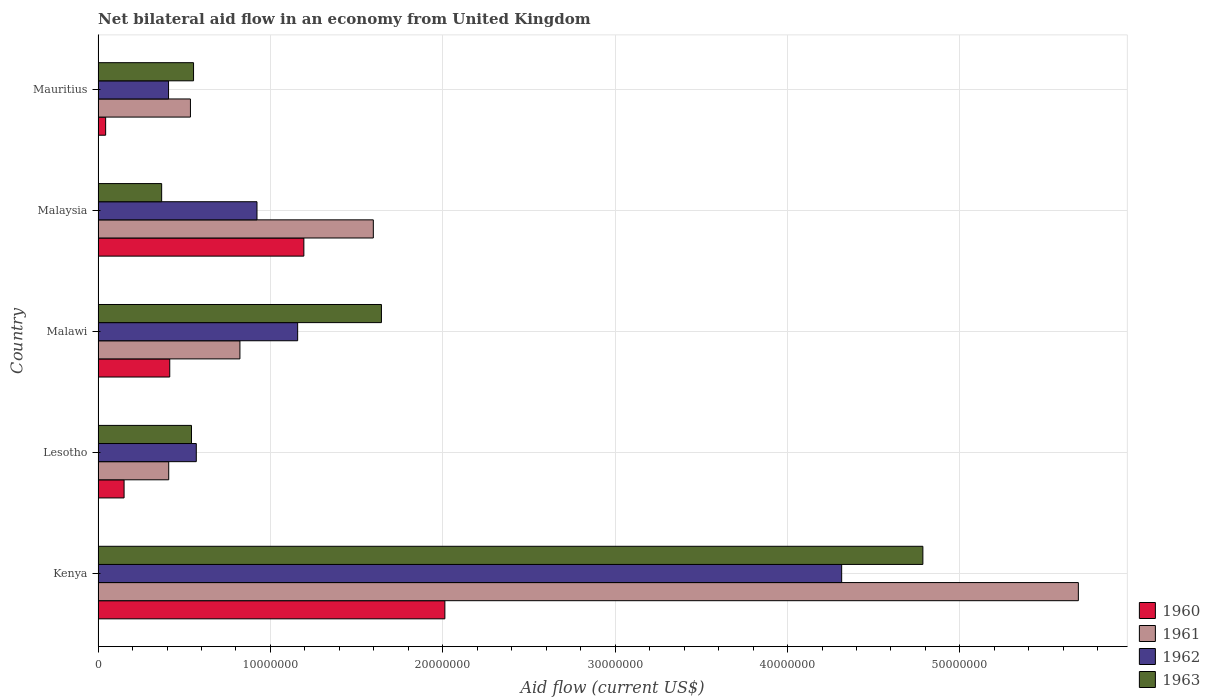How many different coloured bars are there?
Provide a succinct answer. 4. How many groups of bars are there?
Make the answer very short. 5. Are the number of bars per tick equal to the number of legend labels?
Ensure brevity in your answer.  Yes. Are the number of bars on each tick of the Y-axis equal?
Ensure brevity in your answer.  Yes. How many bars are there on the 5th tick from the top?
Your answer should be very brief. 4. What is the label of the 1st group of bars from the top?
Ensure brevity in your answer.  Mauritius. What is the net bilateral aid flow in 1960 in Malawi?
Ensure brevity in your answer.  4.16e+06. Across all countries, what is the maximum net bilateral aid flow in 1960?
Provide a short and direct response. 2.01e+07. Across all countries, what is the minimum net bilateral aid flow in 1963?
Offer a very short reply. 3.69e+06. In which country was the net bilateral aid flow in 1962 maximum?
Keep it short and to the point. Kenya. In which country was the net bilateral aid flow in 1960 minimum?
Your answer should be compact. Mauritius. What is the total net bilateral aid flow in 1962 in the graph?
Give a very brief answer. 7.37e+07. What is the difference between the net bilateral aid flow in 1962 in Malawi and that in Malaysia?
Your answer should be compact. 2.36e+06. What is the difference between the net bilateral aid flow in 1963 in Malaysia and the net bilateral aid flow in 1961 in Kenya?
Offer a very short reply. -5.32e+07. What is the average net bilateral aid flow in 1960 per country?
Keep it short and to the point. 7.63e+06. What is the difference between the net bilateral aid flow in 1961 and net bilateral aid flow in 1962 in Kenya?
Your answer should be compact. 1.37e+07. In how many countries, is the net bilateral aid flow in 1960 greater than 14000000 US$?
Keep it short and to the point. 1. What is the ratio of the net bilateral aid flow in 1963 in Kenya to that in Malaysia?
Make the answer very short. 12.97. Is the net bilateral aid flow in 1962 in Malaysia less than that in Mauritius?
Your answer should be compact. No. Is the difference between the net bilateral aid flow in 1961 in Kenya and Mauritius greater than the difference between the net bilateral aid flow in 1962 in Kenya and Mauritius?
Offer a terse response. Yes. What is the difference between the highest and the second highest net bilateral aid flow in 1962?
Your answer should be compact. 3.16e+07. What is the difference between the highest and the lowest net bilateral aid flow in 1963?
Offer a very short reply. 4.42e+07. In how many countries, is the net bilateral aid flow in 1963 greater than the average net bilateral aid flow in 1963 taken over all countries?
Provide a short and direct response. 2. What does the 3rd bar from the bottom in Kenya represents?
Offer a terse response. 1962. How many bars are there?
Your answer should be very brief. 20. How many countries are there in the graph?
Give a very brief answer. 5. What is the difference between two consecutive major ticks on the X-axis?
Keep it short and to the point. 1.00e+07. Are the values on the major ticks of X-axis written in scientific E-notation?
Keep it short and to the point. No. Does the graph contain any zero values?
Offer a terse response. No. Where does the legend appear in the graph?
Offer a terse response. Bottom right. How are the legend labels stacked?
Offer a terse response. Vertical. What is the title of the graph?
Keep it short and to the point. Net bilateral aid flow in an economy from United Kingdom. What is the label or title of the X-axis?
Ensure brevity in your answer.  Aid flow (current US$). What is the label or title of the Y-axis?
Your response must be concise. Country. What is the Aid flow (current US$) in 1960 in Kenya?
Provide a succinct answer. 2.01e+07. What is the Aid flow (current US$) in 1961 in Kenya?
Provide a short and direct response. 5.69e+07. What is the Aid flow (current US$) in 1962 in Kenya?
Your response must be concise. 4.31e+07. What is the Aid flow (current US$) in 1963 in Kenya?
Offer a terse response. 4.78e+07. What is the Aid flow (current US$) of 1960 in Lesotho?
Make the answer very short. 1.51e+06. What is the Aid flow (current US$) in 1961 in Lesotho?
Give a very brief answer. 4.10e+06. What is the Aid flow (current US$) of 1962 in Lesotho?
Offer a very short reply. 5.70e+06. What is the Aid flow (current US$) in 1963 in Lesotho?
Keep it short and to the point. 5.42e+06. What is the Aid flow (current US$) of 1960 in Malawi?
Your answer should be very brief. 4.16e+06. What is the Aid flow (current US$) of 1961 in Malawi?
Make the answer very short. 8.23e+06. What is the Aid flow (current US$) of 1962 in Malawi?
Your answer should be very brief. 1.16e+07. What is the Aid flow (current US$) of 1963 in Malawi?
Give a very brief answer. 1.64e+07. What is the Aid flow (current US$) in 1960 in Malaysia?
Offer a terse response. 1.19e+07. What is the Aid flow (current US$) of 1961 in Malaysia?
Your answer should be compact. 1.60e+07. What is the Aid flow (current US$) in 1962 in Malaysia?
Make the answer very short. 9.22e+06. What is the Aid flow (current US$) of 1963 in Malaysia?
Keep it short and to the point. 3.69e+06. What is the Aid flow (current US$) of 1960 in Mauritius?
Give a very brief answer. 4.40e+05. What is the Aid flow (current US$) in 1961 in Mauritius?
Make the answer very short. 5.36e+06. What is the Aid flow (current US$) in 1962 in Mauritius?
Ensure brevity in your answer.  4.09e+06. What is the Aid flow (current US$) in 1963 in Mauritius?
Offer a terse response. 5.54e+06. Across all countries, what is the maximum Aid flow (current US$) of 1960?
Keep it short and to the point. 2.01e+07. Across all countries, what is the maximum Aid flow (current US$) in 1961?
Provide a short and direct response. 5.69e+07. Across all countries, what is the maximum Aid flow (current US$) in 1962?
Ensure brevity in your answer.  4.31e+07. Across all countries, what is the maximum Aid flow (current US$) of 1963?
Give a very brief answer. 4.78e+07. Across all countries, what is the minimum Aid flow (current US$) in 1961?
Make the answer very short. 4.10e+06. Across all countries, what is the minimum Aid flow (current US$) in 1962?
Provide a short and direct response. 4.09e+06. Across all countries, what is the minimum Aid flow (current US$) of 1963?
Offer a very short reply. 3.69e+06. What is the total Aid flow (current US$) in 1960 in the graph?
Your response must be concise. 3.82e+07. What is the total Aid flow (current US$) in 1961 in the graph?
Offer a very short reply. 9.05e+07. What is the total Aid flow (current US$) of 1962 in the graph?
Offer a terse response. 7.37e+07. What is the total Aid flow (current US$) of 1963 in the graph?
Keep it short and to the point. 7.89e+07. What is the difference between the Aid flow (current US$) in 1960 in Kenya and that in Lesotho?
Provide a short and direct response. 1.86e+07. What is the difference between the Aid flow (current US$) of 1961 in Kenya and that in Lesotho?
Ensure brevity in your answer.  5.28e+07. What is the difference between the Aid flow (current US$) in 1962 in Kenya and that in Lesotho?
Your response must be concise. 3.74e+07. What is the difference between the Aid flow (current US$) in 1963 in Kenya and that in Lesotho?
Your answer should be compact. 4.24e+07. What is the difference between the Aid flow (current US$) of 1960 in Kenya and that in Malawi?
Your answer should be very brief. 1.60e+07. What is the difference between the Aid flow (current US$) of 1961 in Kenya and that in Malawi?
Your answer should be very brief. 4.86e+07. What is the difference between the Aid flow (current US$) of 1962 in Kenya and that in Malawi?
Offer a terse response. 3.16e+07. What is the difference between the Aid flow (current US$) of 1963 in Kenya and that in Malawi?
Ensure brevity in your answer.  3.14e+07. What is the difference between the Aid flow (current US$) of 1960 in Kenya and that in Malaysia?
Make the answer very short. 8.18e+06. What is the difference between the Aid flow (current US$) in 1961 in Kenya and that in Malaysia?
Your answer should be compact. 4.09e+07. What is the difference between the Aid flow (current US$) in 1962 in Kenya and that in Malaysia?
Ensure brevity in your answer.  3.39e+07. What is the difference between the Aid flow (current US$) in 1963 in Kenya and that in Malaysia?
Provide a short and direct response. 4.42e+07. What is the difference between the Aid flow (current US$) of 1960 in Kenya and that in Mauritius?
Ensure brevity in your answer.  1.97e+07. What is the difference between the Aid flow (current US$) of 1961 in Kenya and that in Mauritius?
Ensure brevity in your answer.  5.15e+07. What is the difference between the Aid flow (current US$) in 1962 in Kenya and that in Mauritius?
Offer a terse response. 3.90e+07. What is the difference between the Aid flow (current US$) in 1963 in Kenya and that in Mauritius?
Offer a very short reply. 4.23e+07. What is the difference between the Aid flow (current US$) of 1960 in Lesotho and that in Malawi?
Provide a short and direct response. -2.65e+06. What is the difference between the Aid flow (current US$) of 1961 in Lesotho and that in Malawi?
Offer a very short reply. -4.13e+06. What is the difference between the Aid flow (current US$) in 1962 in Lesotho and that in Malawi?
Ensure brevity in your answer.  -5.88e+06. What is the difference between the Aid flow (current US$) in 1963 in Lesotho and that in Malawi?
Make the answer very short. -1.10e+07. What is the difference between the Aid flow (current US$) of 1960 in Lesotho and that in Malaysia?
Provide a succinct answer. -1.04e+07. What is the difference between the Aid flow (current US$) of 1961 in Lesotho and that in Malaysia?
Give a very brief answer. -1.19e+07. What is the difference between the Aid flow (current US$) in 1962 in Lesotho and that in Malaysia?
Make the answer very short. -3.52e+06. What is the difference between the Aid flow (current US$) in 1963 in Lesotho and that in Malaysia?
Your response must be concise. 1.73e+06. What is the difference between the Aid flow (current US$) in 1960 in Lesotho and that in Mauritius?
Ensure brevity in your answer.  1.07e+06. What is the difference between the Aid flow (current US$) of 1961 in Lesotho and that in Mauritius?
Keep it short and to the point. -1.26e+06. What is the difference between the Aid flow (current US$) in 1962 in Lesotho and that in Mauritius?
Your response must be concise. 1.61e+06. What is the difference between the Aid flow (current US$) in 1960 in Malawi and that in Malaysia?
Provide a succinct answer. -7.78e+06. What is the difference between the Aid flow (current US$) of 1961 in Malawi and that in Malaysia?
Ensure brevity in your answer.  -7.74e+06. What is the difference between the Aid flow (current US$) in 1962 in Malawi and that in Malaysia?
Offer a very short reply. 2.36e+06. What is the difference between the Aid flow (current US$) of 1963 in Malawi and that in Malaysia?
Provide a short and direct response. 1.28e+07. What is the difference between the Aid flow (current US$) in 1960 in Malawi and that in Mauritius?
Offer a terse response. 3.72e+06. What is the difference between the Aid flow (current US$) in 1961 in Malawi and that in Mauritius?
Make the answer very short. 2.87e+06. What is the difference between the Aid flow (current US$) in 1962 in Malawi and that in Mauritius?
Your answer should be compact. 7.49e+06. What is the difference between the Aid flow (current US$) of 1963 in Malawi and that in Mauritius?
Provide a succinct answer. 1.09e+07. What is the difference between the Aid flow (current US$) in 1960 in Malaysia and that in Mauritius?
Keep it short and to the point. 1.15e+07. What is the difference between the Aid flow (current US$) in 1961 in Malaysia and that in Mauritius?
Provide a succinct answer. 1.06e+07. What is the difference between the Aid flow (current US$) of 1962 in Malaysia and that in Mauritius?
Give a very brief answer. 5.13e+06. What is the difference between the Aid flow (current US$) of 1963 in Malaysia and that in Mauritius?
Offer a terse response. -1.85e+06. What is the difference between the Aid flow (current US$) in 1960 in Kenya and the Aid flow (current US$) in 1961 in Lesotho?
Keep it short and to the point. 1.60e+07. What is the difference between the Aid flow (current US$) in 1960 in Kenya and the Aid flow (current US$) in 1962 in Lesotho?
Keep it short and to the point. 1.44e+07. What is the difference between the Aid flow (current US$) of 1960 in Kenya and the Aid flow (current US$) of 1963 in Lesotho?
Keep it short and to the point. 1.47e+07. What is the difference between the Aid flow (current US$) in 1961 in Kenya and the Aid flow (current US$) in 1962 in Lesotho?
Offer a terse response. 5.12e+07. What is the difference between the Aid flow (current US$) of 1961 in Kenya and the Aid flow (current US$) of 1963 in Lesotho?
Keep it short and to the point. 5.14e+07. What is the difference between the Aid flow (current US$) of 1962 in Kenya and the Aid flow (current US$) of 1963 in Lesotho?
Provide a succinct answer. 3.77e+07. What is the difference between the Aid flow (current US$) of 1960 in Kenya and the Aid flow (current US$) of 1961 in Malawi?
Provide a succinct answer. 1.19e+07. What is the difference between the Aid flow (current US$) in 1960 in Kenya and the Aid flow (current US$) in 1962 in Malawi?
Offer a terse response. 8.54e+06. What is the difference between the Aid flow (current US$) in 1960 in Kenya and the Aid flow (current US$) in 1963 in Malawi?
Your answer should be compact. 3.68e+06. What is the difference between the Aid flow (current US$) in 1961 in Kenya and the Aid flow (current US$) in 1962 in Malawi?
Make the answer very short. 4.53e+07. What is the difference between the Aid flow (current US$) in 1961 in Kenya and the Aid flow (current US$) in 1963 in Malawi?
Keep it short and to the point. 4.04e+07. What is the difference between the Aid flow (current US$) of 1962 in Kenya and the Aid flow (current US$) of 1963 in Malawi?
Offer a terse response. 2.67e+07. What is the difference between the Aid flow (current US$) in 1960 in Kenya and the Aid flow (current US$) in 1961 in Malaysia?
Offer a terse response. 4.15e+06. What is the difference between the Aid flow (current US$) in 1960 in Kenya and the Aid flow (current US$) in 1962 in Malaysia?
Offer a very short reply. 1.09e+07. What is the difference between the Aid flow (current US$) in 1960 in Kenya and the Aid flow (current US$) in 1963 in Malaysia?
Your answer should be compact. 1.64e+07. What is the difference between the Aid flow (current US$) in 1961 in Kenya and the Aid flow (current US$) in 1962 in Malaysia?
Offer a terse response. 4.76e+07. What is the difference between the Aid flow (current US$) of 1961 in Kenya and the Aid flow (current US$) of 1963 in Malaysia?
Give a very brief answer. 5.32e+07. What is the difference between the Aid flow (current US$) of 1962 in Kenya and the Aid flow (current US$) of 1963 in Malaysia?
Ensure brevity in your answer.  3.94e+07. What is the difference between the Aid flow (current US$) of 1960 in Kenya and the Aid flow (current US$) of 1961 in Mauritius?
Offer a very short reply. 1.48e+07. What is the difference between the Aid flow (current US$) in 1960 in Kenya and the Aid flow (current US$) in 1962 in Mauritius?
Ensure brevity in your answer.  1.60e+07. What is the difference between the Aid flow (current US$) of 1960 in Kenya and the Aid flow (current US$) of 1963 in Mauritius?
Make the answer very short. 1.46e+07. What is the difference between the Aid flow (current US$) of 1961 in Kenya and the Aid flow (current US$) of 1962 in Mauritius?
Make the answer very short. 5.28e+07. What is the difference between the Aid flow (current US$) of 1961 in Kenya and the Aid flow (current US$) of 1963 in Mauritius?
Provide a short and direct response. 5.13e+07. What is the difference between the Aid flow (current US$) of 1962 in Kenya and the Aid flow (current US$) of 1963 in Mauritius?
Your answer should be very brief. 3.76e+07. What is the difference between the Aid flow (current US$) of 1960 in Lesotho and the Aid flow (current US$) of 1961 in Malawi?
Your response must be concise. -6.72e+06. What is the difference between the Aid flow (current US$) of 1960 in Lesotho and the Aid flow (current US$) of 1962 in Malawi?
Your answer should be very brief. -1.01e+07. What is the difference between the Aid flow (current US$) in 1960 in Lesotho and the Aid flow (current US$) in 1963 in Malawi?
Offer a very short reply. -1.49e+07. What is the difference between the Aid flow (current US$) in 1961 in Lesotho and the Aid flow (current US$) in 1962 in Malawi?
Your answer should be compact. -7.48e+06. What is the difference between the Aid flow (current US$) of 1961 in Lesotho and the Aid flow (current US$) of 1963 in Malawi?
Your response must be concise. -1.23e+07. What is the difference between the Aid flow (current US$) of 1962 in Lesotho and the Aid flow (current US$) of 1963 in Malawi?
Provide a short and direct response. -1.07e+07. What is the difference between the Aid flow (current US$) of 1960 in Lesotho and the Aid flow (current US$) of 1961 in Malaysia?
Your answer should be very brief. -1.45e+07. What is the difference between the Aid flow (current US$) in 1960 in Lesotho and the Aid flow (current US$) in 1962 in Malaysia?
Your answer should be very brief. -7.71e+06. What is the difference between the Aid flow (current US$) of 1960 in Lesotho and the Aid flow (current US$) of 1963 in Malaysia?
Keep it short and to the point. -2.18e+06. What is the difference between the Aid flow (current US$) of 1961 in Lesotho and the Aid flow (current US$) of 1962 in Malaysia?
Give a very brief answer. -5.12e+06. What is the difference between the Aid flow (current US$) of 1962 in Lesotho and the Aid flow (current US$) of 1963 in Malaysia?
Ensure brevity in your answer.  2.01e+06. What is the difference between the Aid flow (current US$) of 1960 in Lesotho and the Aid flow (current US$) of 1961 in Mauritius?
Keep it short and to the point. -3.85e+06. What is the difference between the Aid flow (current US$) of 1960 in Lesotho and the Aid flow (current US$) of 1962 in Mauritius?
Provide a succinct answer. -2.58e+06. What is the difference between the Aid flow (current US$) in 1960 in Lesotho and the Aid flow (current US$) in 1963 in Mauritius?
Your answer should be very brief. -4.03e+06. What is the difference between the Aid flow (current US$) in 1961 in Lesotho and the Aid flow (current US$) in 1962 in Mauritius?
Ensure brevity in your answer.  10000. What is the difference between the Aid flow (current US$) of 1961 in Lesotho and the Aid flow (current US$) of 1963 in Mauritius?
Your answer should be compact. -1.44e+06. What is the difference between the Aid flow (current US$) in 1962 in Lesotho and the Aid flow (current US$) in 1963 in Mauritius?
Your response must be concise. 1.60e+05. What is the difference between the Aid flow (current US$) in 1960 in Malawi and the Aid flow (current US$) in 1961 in Malaysia?
Provide a succinct answer. -1.18e+07. What is the difference between the Aid flow (current US$) of 1960 in Malawi and the Aid flow (current US$) of 1962 in Malaysia?
Offer a very short reply. -5.06e+06. What is the difference between the Aid flow (current US$) in 1960 in Malawi and the Aid flow (current US$) in 1963 in Malaysia?
Offer a terse response. 4.70e+05. What is the difference between the Aid flow (current US$) of 1961 in Malawi and the Aid flow (current US$) of 1962 in Malaysia?
Your answer should be very brief. -9.90e+05. What is the difference between the Aid flow (current US$) in 1961 in Malawi and the Aid flow (current US$) in 1963 in Malaysia?
Provide a succinct answer. 4.54e+06. What is the difference between the Aid flow (current US$) of 1962 in Malawi and the Aid flow (current US$) of 1963 in Malaysia?
Your answer should be very brief. 7.89e+06. What is the difference between the Aid flow (current US$) in 1960 in Malawi and the Aid flow (current US$) in 1961 in Mauritius?
Your response must be concise. -1.20e+06. What is the difference between the Aid flow (current US$) of 1960 in Malawi and the Aid flow (current US$) of 1962 in Mauritius?
Provide a short and direct response. 7.00e+04. What is the difference between the Aid flow (current US$) in 1960 in Malawi and the Aid flow (current US$) in 1963 in Mauritius?
Ensure brevity in your answer.  -1.38e+06. What is the difference between the Aid flow (current US$) of 1961 in Malawi and the Aid flow (current US$) of 1962 in Mauritius?
Your response must be concise. 4.14e+06. What is the difference between the Aid flow (current US$) in 1961 in Malawi and the Aid flow (current US$) in 1963 in Mauritius?
Give a very brief answer. 2.69e+06. What is the difference between the Aid flow (current US$) of 1962 in Malawi and the Aid flow (current US$) of 1963 in Mauritius?
Ensure brevity in your answer.  6.04e+06. What is the difference between the Aid flow (current US$) in 1960 in Malaysia and the Aid flow (current US$) in 1961 in Mauritius?
Offer a very short reply. 6.58e+06. What is the difference between the Aid flow (current US$) of 1960 in Malaysia and the Aid flow (current US$) of 1962 in Mauritius?
Provide a succinct answer. 7.85e+06. What is the difference between the Aid flow (current US$) of 1960 in Malaysia and the Aid flow (current US$) of 1963 in Mauritius?
Your answer should be very brief. 6.40e+06. What is the difference between the Aid flow (current US$) in 1961 in Malaysia and the Aid flow (current US$) in 1962 in Mauritius?
Your answer should be very brief. 1.19e+07. What is the difference between the Aid flow (current US$) of 1961 in Malaysia and the Aid flow (current US$) of 1963 in Mauritius?
Offer a terse response. 1.04e+07. What is the difference between the Aid flow (current US$) of 1962 in Malaysia and the Aid flow (current US$) of 1963 in Mauritius?
Give a very brief answer. 3.68e+06. What is the average Aid flow (current US$) of 1960 per country?
Offer a very short reply. 7.63e+06. What is the average Aid flow (current US$) in 1961 per country?
Make the answer very short. 1.81e+07. What is the average Aid flow (current US$) in 1962 per country?
Make the answer very short. 1.47e+07. What is the average Aid flow (current US$) of 1963 per country?
Offer a terse response. 1.58e+07. What is the difference between the Aid flow (current US$) in 1960 and Aid flow (current US$) in 1961 in Kenya?
Your answer should be very brief. -3.68e+07. What is the difference between the Aid flow (current US$) of 1960 and Aid flow (current US$) of 1962 in Kenya?
Provide a succinct answer. -2.30e+07. What is the difference between the Aid flow (current US$) of 1960 and Aid flow (current US$) of 1963 in Kenya?
Give a very brief answer. -2.77e+07. What is the difference between the Aid flow (current US$) of 1961 and Aid flow (current US$) of 1962 in Kenya?
Offer a very short reply. 1.37e+07. What is the difference between the Aid flow (current US$) in 1961 and Aid flow (current US$) in 1963 in Kenya?
Provide a short and direct response. 9.02e+06. What is the difference between the Aid flow (current US$) in 1962 and Aid flow (current US$) in 1963 in Kenya?
Keep it short and to the point. -4.71e+06. What is the difference between the Aid flow (current US$) of 1960 and Aid flow (current US$) of 1961 in Lesotho?
Your answer should be very brief. -2.59e+06. What is the difference between the Aid flow (current US$) of 1960 and Aid flow (current US$) of 1962 in Lesotho?
Your answer should be compact. -4.19e+06. What is the difference between the Aid flow (current US$) of 1960 and Aid flow (current US$) of 1963 in Lesotho?
Provide a short and direct response. -3.91e+06. What is the difference between the Aid flow (current US$) in 1961 and Aid flow (current US$) in 1962 in Lesotho?
Provide a short and direct response. -1.60e+06. What is the difference between the Aid flow (current US$) in 1961 and Aid flow (current US$) in 1963 in Lesotho?
Keep it short and to the point. -1.32e+06. What is the difference between the Aid flow (current US$) of 1962 and Aid flow (current US$) of 1963 in Lesotho?
Provide a short and direct response. 2.80e+05. What is the difference between the Aid flow (current US$) in 1960 and Aid flow (current US$) in 1961 in Malawi?
Give a very brief answer. -4.07e+06. What is the difference between the Aid flow (current US$) of 1960 and Aid flow (current US$) of 1962 in Malawi?
Provide a short and direct response. -7.42e+06. What is the difference between the Aid flow (current US$) in 1960 and Aid flow (current US$) in 1963 in Malawi?
Keep it short and to the point. -1.23e+07. What is the difference between the Aid flow (current US$) of 1961 and Aid flow (current US$) of 1962 in Malawi?
Provide a short and direct response. -3.35e+06. What is the difference between the Aid flow (current US$) in 1961 and Aid flow (current US$) in 1963 in Malawi?
Your answer should be compact. -8.21e+06. What is the difference between the Aid flow (current US$) of 1962 and Aid flow (current US$) of 1963 in Malawi?
Provide a succinct answer. -4.86e+06. What is the difference between the Aid flow (current US$) of 1960 and Aid flow (current US$) of 1961 in Malaysia?
Keep it short and to the point. -4.03e+06. What is the difference between the Aid flow (current US$) in 1960 and Aid flow (current US$) in 1962 in Malaysia?
Make the answer very short. 2.72e+06. What is the difference between the Aid flow (current US$) in 1960 and Aid flow (current US$) in 1963 in Malaysia?
Your answer should be compact. 8.25e+06. What is the difference between the Aid flow (current US$) of 1961 and Aid flow (current US$) of 1962 in Malaysia?
Your answer should be compact. 6.75e+06. What is the difference between the Aid flow (current US$) in 1961 and Aid flow (current US$) in 1963 in Malaysia?
Keep it short and to the point. 1.23e+07. What is the difference between the Aid flow (current US$) of 1962 and Aid flow (current US$) of 1963 in Malaysia?
Your answer should be compact. 5.53e+06. What is the difference between the Aid flow (current US$) in 1960 and Aid flow (current US$) in 1961 in Mauritius?
Ensure brevity in your answer.  -4.92e+06. What is the difference between the Aid flow (current US$) of 1960 and Aid flow (current US$) of 1962 in Mauritius?
Provide a succinct answer. -3.65e+06. What is the difference between the Aid flow (current US$) in 1960 and Aid flow (current US$) in 1963 in Mauritius?
Your answer should be very brief. -5.10e+06. What is the difference between the Aid flow (current US$) of 1961 and Aid flow (current US$) of 1962 in Mauritius?
Provide a short and direct response. 1.27e+06. What is the difference between the Aid flow (current US$) of 1961 and Aid flow (current US$) of 1963 in Mauritius?
Your response must be concise. -1.80e+05. What is the difference between the Aid flow (current US$) of 1962 and Aid flow (current US$) of 1963 in Mauritius?
Ensure brevity in your answer.  -1.45e+06. What is the ratio of the Aid flow (current US$) of 1960 in Kenya to that in Lesotho?
Provide a succinct answer. 13.32. What is the ratio of the Aid flow (current US$) of 1961 in Kenya to that in Lesotho?
Provide a short and direct response. 13.87. What is the ratio of the Aid flow (current US$) of 1962 in Kenya to that in Lesotho?
Keep it short and to the point. 7.57. What is the ratio of the Aid flow (current US$) in 1963 in Kenya to that in Lesotho?
Keep it short and to the point. 8.83. What is the ratio of the Aid flow (current US$) of 1960 in Kenya to that in Malawi?
Give a very brief answer. 4.84. What is the ratio of the Aid flow (current US$) in 1961 in Kenya to that in Malawi?
Provide a short and direct response. 6.91. What is the ratio of the Aid flow (current US$) in 1962 in Kenya to that in Malawi?
Offer a very short reply. 3.73. What is the ratio of the Aid flow (current US$) in 1963 in Kenya to that in Malawi?
Make the answer very short. 2.91. What is the ratio of the Aid flow (current US$) in 1960 in Kenya to that in Malaysia?
Your answer should be compact. 1.69. What is the ratio of the Aid flow (current US$) of 1961 in Kenya to that in Malaysia?
Make the answer very short. 3.56. What is the ratio of the Aid flow (current US$) of 1962 in Kenya to that in Malaysia?
Provide a short and direct response. 4.68. What is the ratio of the Aid flow (current US$) in 1963 in Kenya to that in Malaysia?
Your answer should be very brief. 12.97. What is the ratio of the Aid flow (current US$) of 1960 in Kenya to that in Mauritius?
Keep it short and to the point. 45.73. What is the ratio of the Aid flow (current US$) in 1961 in Kenya to that in Mauritius?
Make the answer very short. 10.61. What is the ratio of the Aid flow (current US$) of 1962 in Kenya to that in Mauritius?
Ensure brevity in your answer.  10.55. What is the ratio of the Aid flow (current US$) of 1963 in Kenya to that in Mauritius?
Give a very brief answer. 8.64. What is the ratio of the Aid flow (current US$) in 1960 in Lesotho to that in Malawi?
Provide a succinct answer. 0.36. What is the ratio of the Aid flow (current US$) of 1961 in Lesotho to that in Malawi?
Provide a short and direct response. 0.5. What is the ratio of the Aid flow (current US$) of 1962 in Lesotho to that in Malawi?
Provide a short and direct response. 0.49. What is the ratio of the Aid flow (current US$) of 1963 in Lesotho to that in Malawi?
Your answer should be compact. 0.33. What is the ratio of the Aid flow (current US$) of 1960 in Lesotho to that in Malaysia?
Your answer should be compact. 0.13. What is the ratio of the Aid flow (current US$) in 1961 in Lesotho to that in Malaysia?
Keep it short and to the point. 0.26. What is the ratio of the Aid flow (current US$) of 1962 in Lesotho to that in Malaysia?
Provide a succinct answer. 0.62. What is the ratio of the Aid flow (current US$) in 1963 in Lesotho to that in Malaysia?
Keep it short and to the point. 1.47. What is the ratio of the Aid flow (current US$) of 1960 in Lesotho to that in Mauritius?
Ensure brevity in your answer.  3.43. What is the ratio of the Aid flow (current US$) of 1961 in Lesotho to that in Mauritius?
Keep it short and to the point. 0.76. What is the ratio of the Aid flow (current US$) in 1962 in Lesotho to that in Mauritius?
Your answer should be compact. 1.39. What is the ratio of the Aid flow (current US$) in 1963 in Lesotho to that in Mauritius?
Your answer should be compact. 0.98. What is the ratio of the Aid flow (current US$) in 1960 in Malawi to that in Malaysia?
Your answer should be compact. 0.35. What is the ratio of the Aid flow (current US$) in 1961 in Malawi to that in Malaysia?
Your answer should be compact. 0.52. What is the ratio of the Aid flow (current US$) in 1962 in Malawi to that in Malaysia?
Offer a terse response. 1.26. What is the ratio of the Aid flow (current US$) in 1963 in Malawi to that in Malaysia?
Offer a terse response. 4.46. What is the ratio of the Aid flow (current US$) in 1960 in Malawi to that in Mauritius?
Your answer should be compact. 9.45. What is the ratio of the Aid flow (current US$) of 1961 in Malawi to that in Mauritius?
Make the answer very short. 1.54. What is the ratio of the Aid flow (current US$) of 1962 in Malawi to that in Mauritius?
Your answer should be compact. 2.83. What is the ratio of the Aid flow (current US$) of 1963 in Malawi to that in Mauritius?
Your answer should be compact. 2.97. What is the ratio of the Aid flow (current US$) in 1960 in Malaysia to that in Mauritius?
Your answer should be very brief. 27.14. What is the ratio of the Aid flow (current US$) in 1961 in Malaysia to that in Mauritius?
Offer a very short reply. 2.98. What is the ratio of the Aid flow (current US$) in 1962 in Malaysia to that in Mauritius?
Make the answer very short. 2.25. What is the ratio of the Aid flow (current US$) in 1963 in Malaysia to that in Mauritius?
Provide a succinct answer. 0.67. What is the difference between the highest and the second highest Aid flow (current US$) in 1960?
Keep it short and to the point. 8.18e+06. What is the difference between the highest and the second highest Aid flow (current US$) in 1961?
Give a very brief answer. 4.09e+07. What is the difference between the highest and the second highest Aid flow (current US$) of 1962?
Your answer should be compact. 3.16e+07. What is the difference between the highest and the second highest Aid flow (current US$) in 1963?
Offer a very short reply. 3.14e+07. What is the difference between the highest and the lowest Aid flow (current US$) in 1960?
Your answer should be very brief. 1.97e+07. What is the difference between the highest and the lowest Aid flow (current US$) of 1961?
Your answer should be very brief. 5.28e+07. What is the difference between the highest and the lowest Aid flow (current US$) in 1962?
Provide a short and direct response. 3.90e+07. What is the difference between the highest and the lowest Aid flow (current US$) in 1963?
Provide a succinct answer. 4.42e+07. 